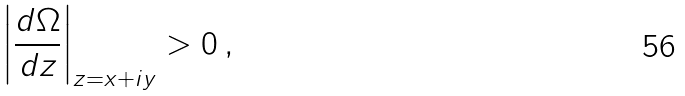Convert formula to latex. <formula><loc_0><loc_0><loc_500><loc_500>\left | { \frac { d \Omega } { d z } } \right | _ { z = x + i y } > 0 \, ,</formula> 